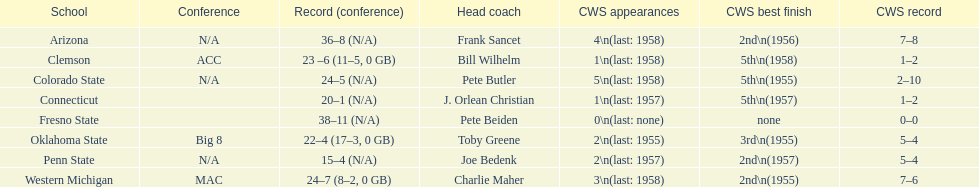Does clemson or western michigan have more cws appearances? Western Michigan. 